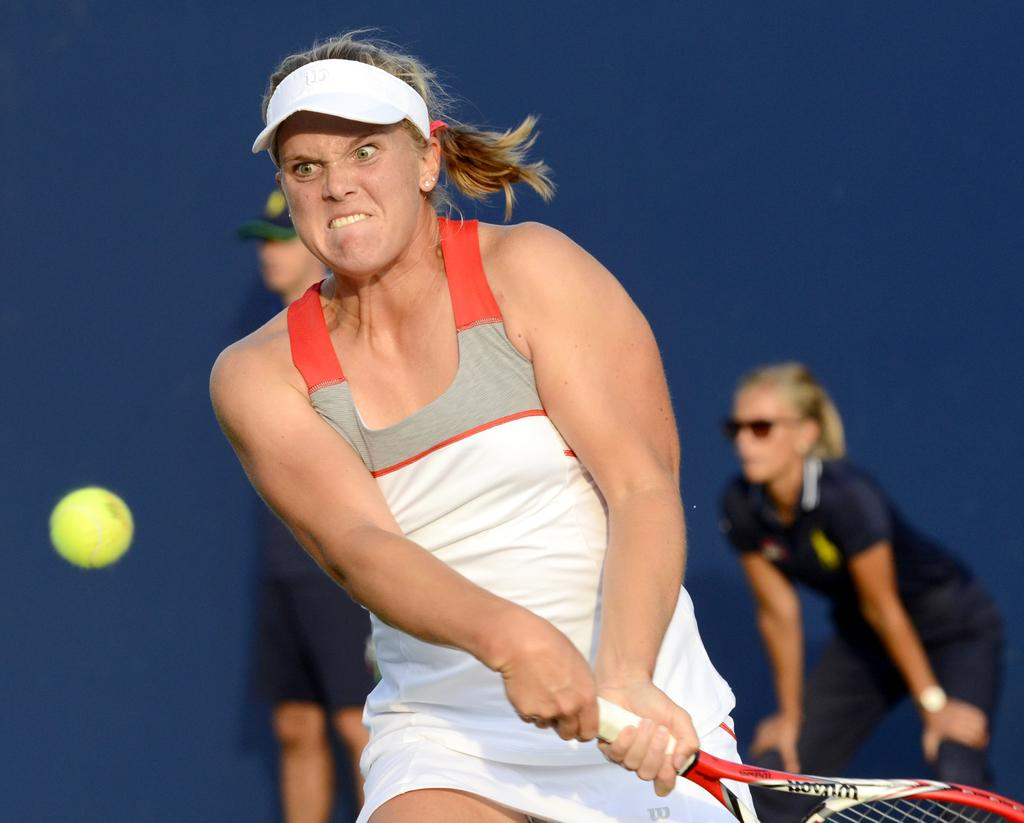What is the person in the center of the image holding? The person is holding a racket in the center of the image. What object is on the left side of the image? There is a ball on the left side of the image. Can you describe the people in the background of the image? There are two more persons standing in the background of the image. Can you see a pump being used by the person holding the racket in the image? There is no pump present in the image; the person is holding a racket and there is a ball on the left side. 